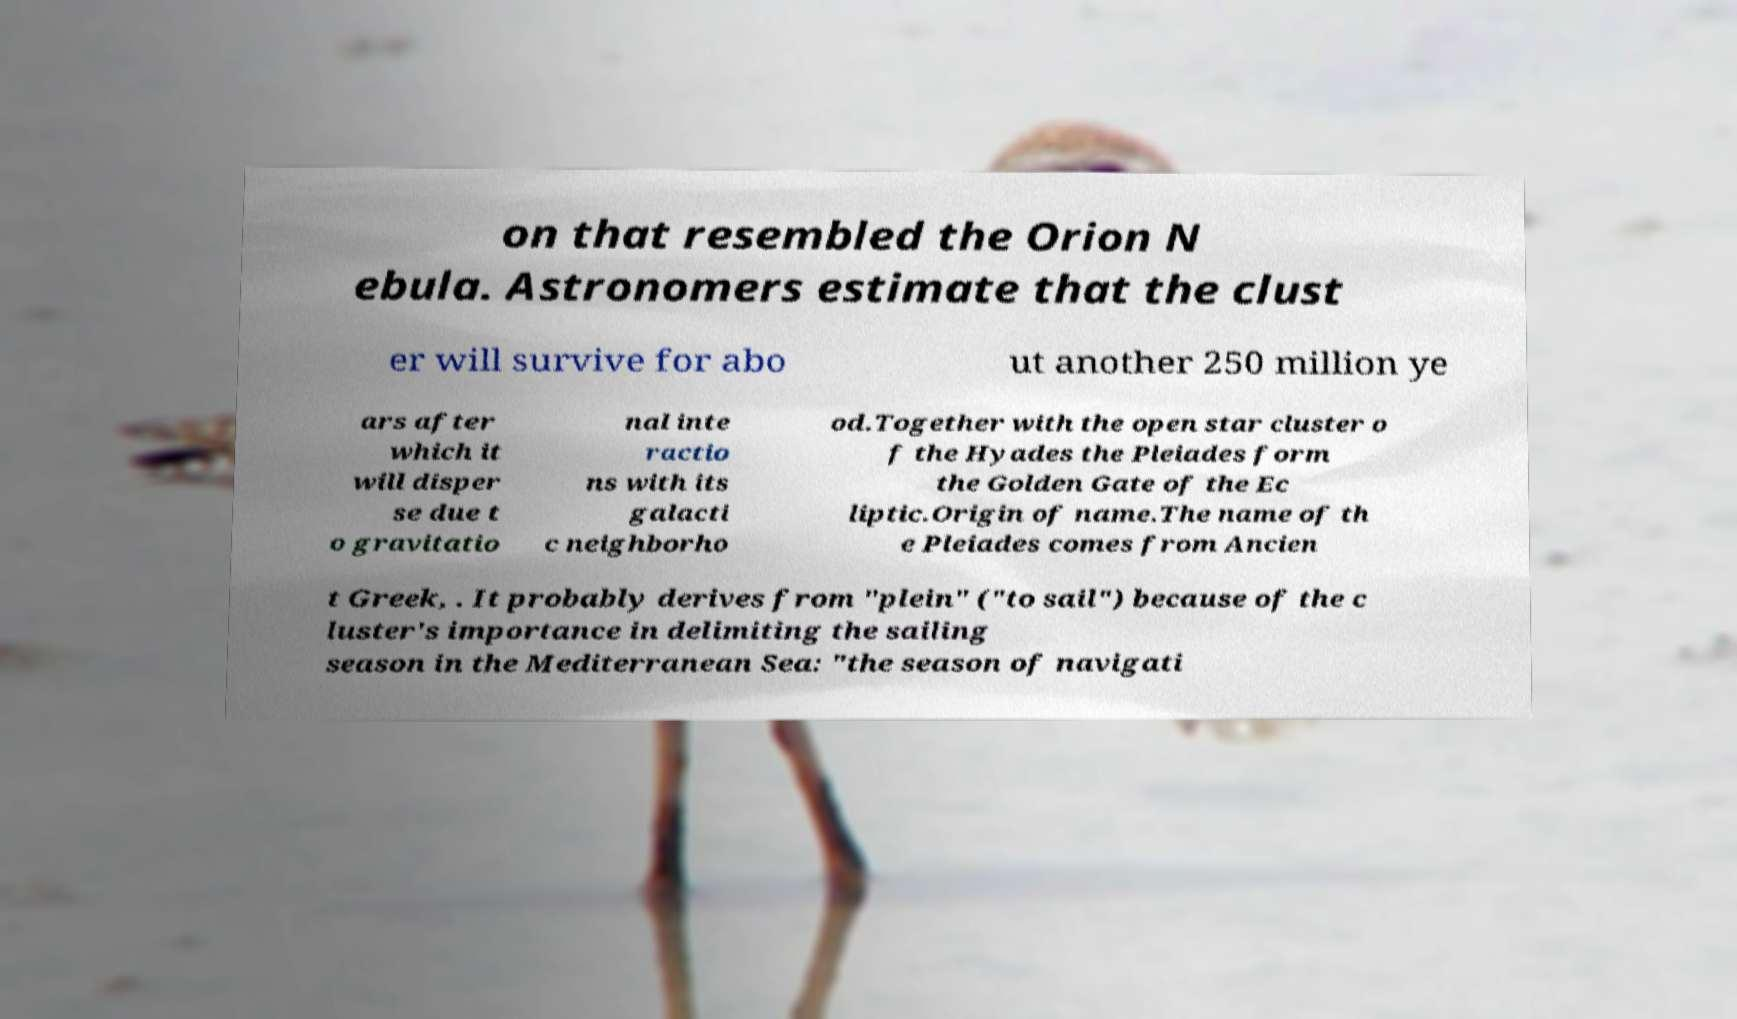Could you assist in decoding the text presented in this image and type it out clearly? on that resembled the Orion N ebula. Astronomers estimate that the clust er will survive for abo ut another 250 million ye ars after which it will disper se due t o gravitatio nal inte ractio ns with its galacti c neighborho od.Together with the open star cluster o f the Hyades the Pleiades form the Golden Gate of the Ec liptic.Origin of name.The name of th e Pleiades comes from Ancien t Greek, . It probably derives from "plein" ("to sail") because of the c luster's importance in delimiting the sailing season in the Mediterranean Sea: "the season of navigati 